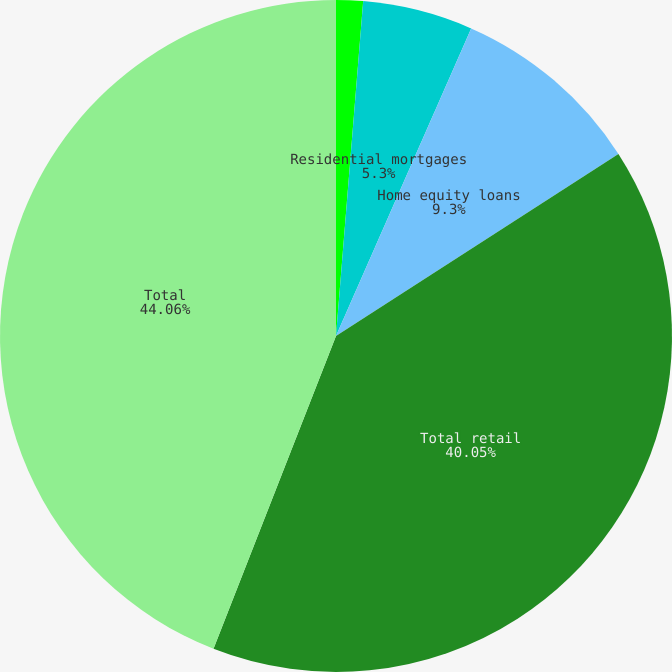<chart> <loc_0><loc_0><loc_500><loc_500><pie_chart><fcel>Total commercial<fcel>Residential mortgages<fcel>Home equity loans<fcel>Total retail<fcel>Total<nl><fcel>1.29%<fcel>5.3%<fcel>9.3%<fcel>40.05%<fcel>44.06%<nl></chart> 